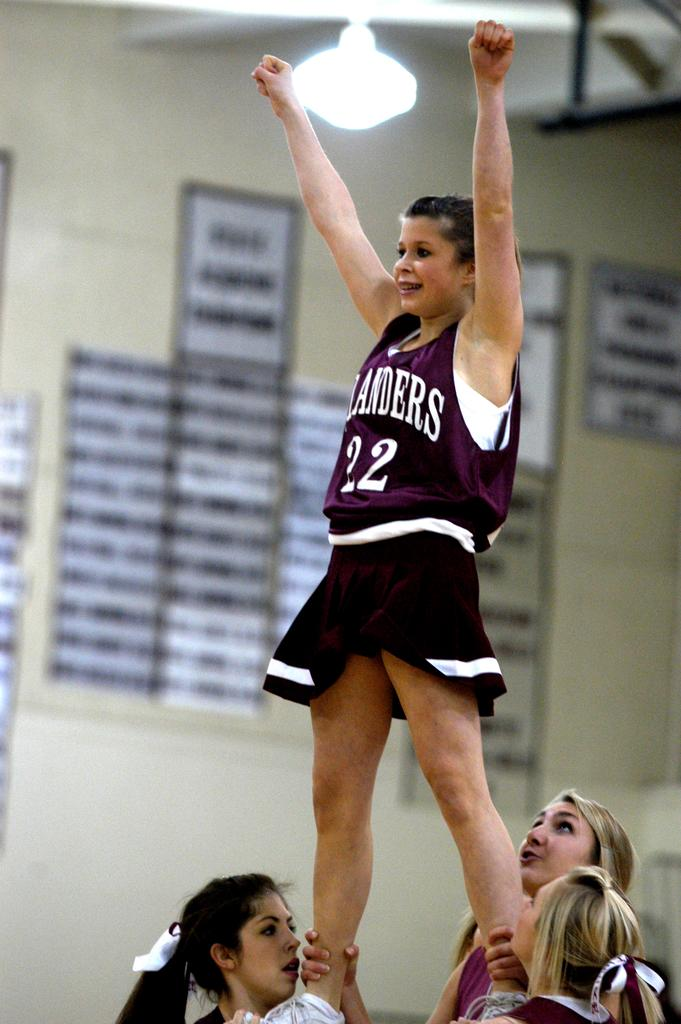<image>
Give a short and clear explanation of the subsequent image. Three cheerleaders pick up another one wearing a Landers outfit. 